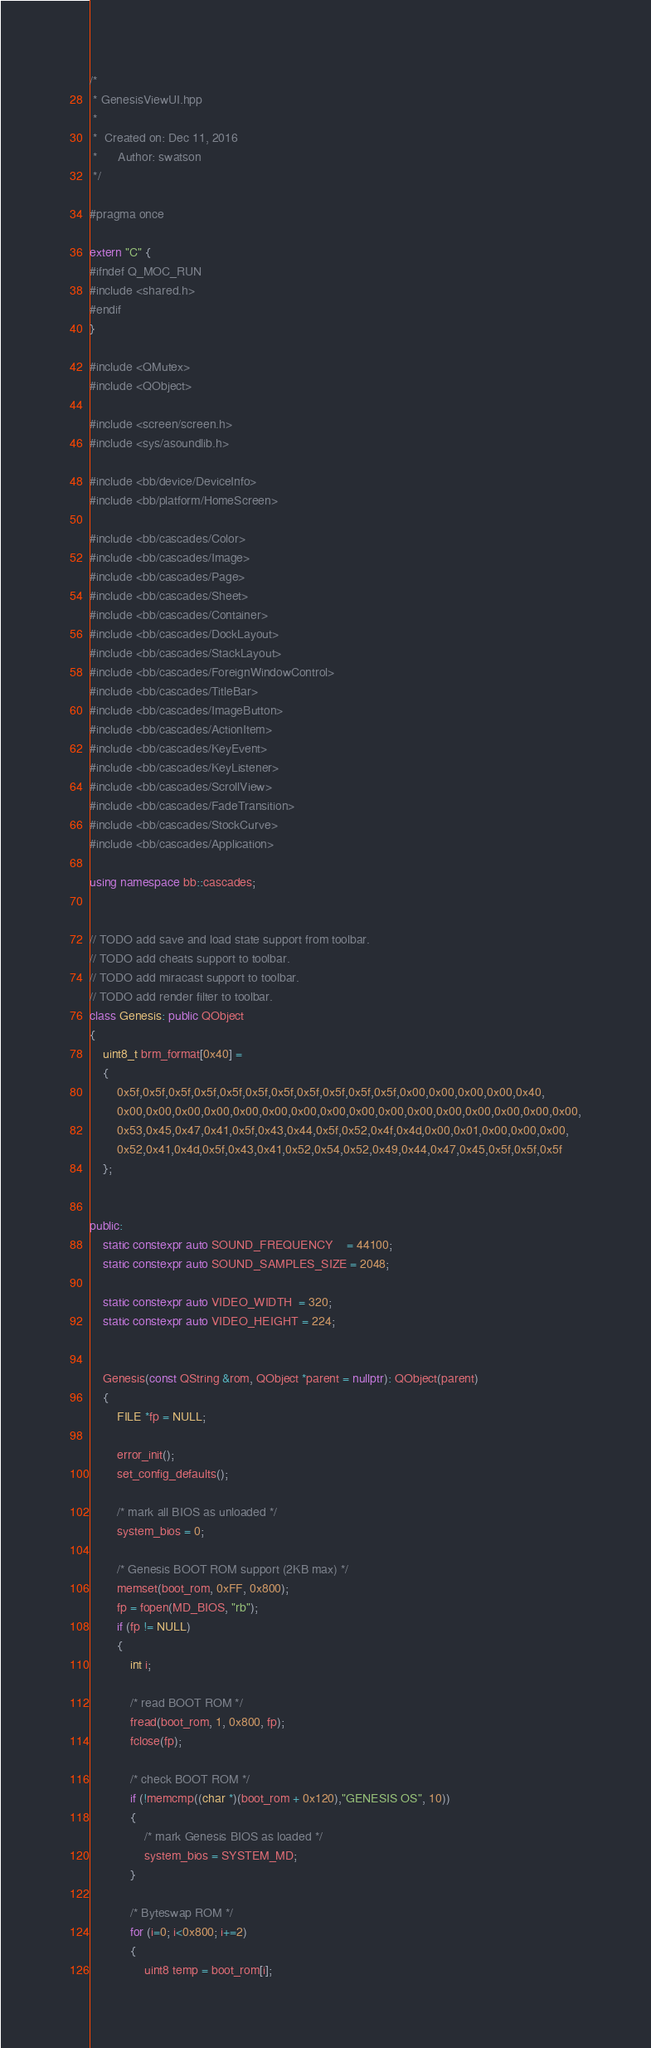<code> <loc_0><loc_0><loc_500><loc_500><_C++_>/*
 * GenesisViewUI.hpp
 *
 *  Created on: Dec 11, 2016
 *      Author: swatson
 */

#pragma once

extern "C" {
#ifndef Q_MOC_RUN
#include <shared.h>
#endif
}

#include <QMutex>
#include <QObject>

#include <screen/screen.h>
#include <sys/asoundlib.h>

#include <bb/device/DeviceInfo>
#include <bb/platform/HomeScreen>

#include <bb/cascades/Color>
#include <bb/cascades/Image>
#include <bb/cascades/Page>
#include <bb/cascades/Sheet>
#include <bb/cascades/Container>
#include <bb/cascades/DockLayout>
#include <bb/cascades/StackLayout>
#include <bb/cascades/ForeignWindowControl>
#include <bb/cascades/TitleBar>
#include <bb/cascades/ImageButton>
#include <bb/cascades/ActionItem>
#include <bb/cascades/KeyEvent>
#include <bb/cascades/KeyListener>
#include <bb/cascades/ScrollView>
#include <bb/cascades/FadeTransition>
#include <bb/cascades/StockCurve>
#include <bb/cascades/Application>

using namespace bb::cascades;


// TODO add save and load state support from toolbar.
// TODO add cheats support to toolbar.
// TODO add miracast support to toolbar.
// TODO add render filter to toolbar.
class Genesis: public QObject
{
    uint8_t brm_format[0x40] =
    {
        0x5f,0x5f,0x5f,0x5f,0x5f,0x5f,0x5f,0x5f,0x5f,0x5f,0x5f,0x00,0x00,0x00,0x00,0x40,
        0x00,0x00,0x00,0x00,0x00,0x00,0x00,0x00,0x00,0x00,0x00,0x00,0x00,0x00,0x00,0x00,
        0x53,0x45,0x47,0x41,0x5f,0x43,0x44,0x5f,0x52,0x4f,0x4d,0x00,0x01,0x00,0x00,0x00,
        0x52,0x41,0x4d,0x5f,0x43,0x41,0x52,0x54,0x52,0x49,0x44,0x47,0x45,0x5f,0x5f,0x5f
    };


public:
    static constexpr auto SOUND_FREQUENCY    = 44100;
    static constexpr auto SOUND_SAMPLES_SIZE = 2048;

    static constexpr auto VIDEO_WIDTH  = 320;
    static constexpr auto VIDEO_HEIGHT = 224;


    Genesis(const QString &rom, QObject *parent = nullptr): QObject(parent)
    {
        FILE *fp = NULL;

        error_init();
        set_config_defaults();

        /* mark all BIOS as unloaded */
        system_bios = 0;

        /* Genesis BOOT ROM support (2KB max) */
        memset(boot_rom, 0xFF, 0x800);
        fp = fopen(MD_BIOS, "rb");
        if (fp != NULL)
        {
            int i;

            /* read BOOT ROM */
            fread(boot_rom, 1, 0x800, fp);
            fclose(fp);

            /* check BOOT ROM */
            if (!memcmp((char *)(boot_rom + 0x120),"GENESIS OS", 10))
            {
                /* mark Genesis BIOS as loaded */
                system_bios = SYSTEM_MD;
            }

            /* Byteswap ROM */
            for (i=0; i<0x800; i+=2)
            {
                uint8 temp = boot_rom[i];</code> 